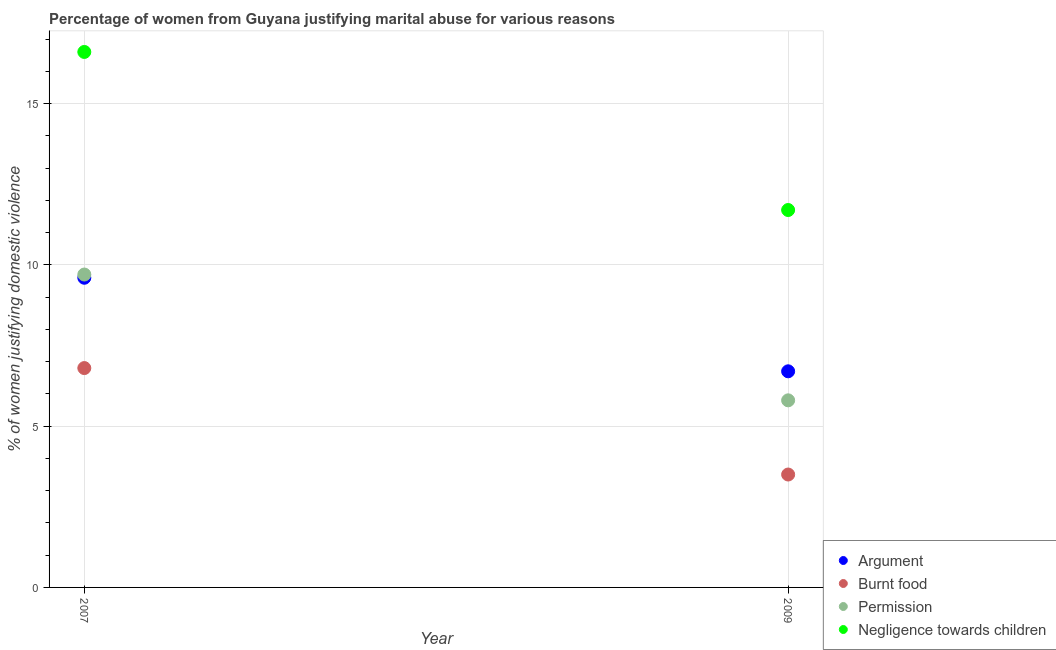How many different coloured dotlines are there?
Provide a short and direct response. 4. In which year was the percentage of women justifying abuse for going without permission maximum?
Your response must be concise. 2007. What is the total percentage of women justifying abuse for showing negligence towards children in the graph?
Offer a very short reply. 28.3. What is the difference between the percentage of women justifying abuse for showing negligence towards children in 2007 and the percentage of women justifying abuse for going without permission in 2009?
Your answer should be compact. 10.8. What is the average percentage of women justifying abuse for burning food per year?
Ensure brevity in your answer.  5.15. In the year 2009, what is the difference between the percentage of women justifying abuse in the case of an argument and percentage of women justifying abuse for burning food?
Offer a terse response. 3.2. In how many years, is the percentage of women justifying abuse in the case of an argument greater than 3 %?
Provide a succinct answer. 2. What is the ratio of the percentage of women justifying abuse for going without permission in 2007 to that in 2009?
Ensure brevity in your answer.  1.67. Is it the case that in every year, the sum of the percentage of women justifying abuse for burning food and percentage of women justifying abuse for showing negligence towards children is greater than the sum of percentage of women justifying abuse in the case of an argument and percentage of women justifying abuse for going without permission?
Offer a very short reply. No. Is it the case that in every year, the sum of the percentage of women justifying abuse in the case of an argument and percentage of women justifying abuse for burning food is greater than the percentage of women justifying abuse for going without permission?
Provide a short and direct response. Yes. Does the percentage of women justifying abuse for showing negligence towards children monotonically increase over the years?
Provide a succinct answer. No. Is the percentage of women justifying abuse for burning food strictly greater than the percentage of women justifying abuse for showing negligence towards children over the years?
Keep it short and to the point. No. How many dotlines are there?
Make the answer very short. 4. Does the graph contain grids?
Your response must be concise. Yes. What is the title of the graph?
Make the answer very short. Percentage of women from Guyana justifying marital abuse for various reasons. Does "Other greenhouse gases" appear as one of the legend labels in the graph?
Ensure brevity in your answer.  No. What is the label or title of the Y-axis?
Offer a very short reply. % of women justifying domestic violence. What is the % of women justifying domestic violence of Argument in 2007?
Keep it short and to the point. 9.6. What is the % of women justifying domestic violence of Burnt food in 2007?
Ensure brevity in your answer.  6.8. What is the % of women justifying domestic violence of Burnt food in 2009?
Provide a succinct answer. 3.5. What is the % of women justifying domestic violence of Permission in 2009?
Make the answer very short. 5.8. Across all years, what is the maximum % of women justifying domestic violence in Permission?
Provide a short and direct response. 9.7. Across all years, what is the maximum % of women justifying domestic violence in Negligence towards children?
Provide a succinct answer. 16.6. Across all years, what is the minimum % of women justifying domestic violence in Argument?
Offer a very short reply. 6.7. Across all years, what is the minimum % of women justifying domestic violence in Permission?
Provide a succinct answer. 5.8. What is the total % of women justifying domestic violence of Argument in the graph?
Your response must be concise. 16.3. What is the total % of women justifying domestic violence in Negligence towards children in the graph?
Keep it short and to the point. 28.3. What is the difference between the % of women justifying domestic violence of Burnt food in 2007 and that in 2009?
Make the answer very short. 3.3. What is the difference between the % of women justifying domestic violence in Argument in 2007 and the % of women justifying domestic violence in Burnt food in 2009?
Offer a very short reply. 6.1. What is the difference between the % of women justifying domestic violence in Argument in 2007 and the % of women justifying domestic violence in Permission in 2009?
Give a very brief answer. 3.8. What is the difference between the % of women justifying domestic violence of Argument in 2007 and the % of women justifying domestic violence of Negligence towards children in 2009?
Your answer should be compact. -2.1. What is the difference between the % of women justifying domestic violence in Burnt food in 2007 and the % of women justifying domestic violence in Permission in 2009?
Make the answer very short. 1. What is the difference between the % of women justifying domestic violence in Burnt food in 2007 and the % of women justifying domestic violence in Negligence towards children in 2009?
Offer a very short reply. -4.9. What is the difference between the % of women justifying domestic violence in Permission in 2007 and the % of women justifying domestic violence in Negligence towards children in 2009?
Your answer should be very brief. -2. What is the average % of women justifying domestic violence in Argument per year?
Give a very brief answer. 8.15. What is the average % of women justifying domestic violence in Burnt food per year?
Keep it short and to the point. 5.15. What is the average % of women justifying domestic violence of Permission per year?
Offer a terse response. 7.75. What is the average % of women justifying domestic violence of Negligence towards children per year?
Ensure brevity in your answer.  14.15. In the year 2007, what is the difference between the % of women justifying domestic violence of Argument and % of women justifying domestic violence of Burnt food?
Keep it short and to the point. 2.8. In the year 2007, what is the difference between the % of women justifying domestic violence in Argument and % of women justifying domestic violence in Permission?
Your answer should be compact. -0.1. In the year 2007, what is the difference between the % of women justifying domestic violence of Argument and % of women justifying domestic violence of Negligence towards children?
Offer a very short reply. -7. In the year 2007, what is the difference between the % of women justifying domestic violence in Burnt food and % of women justifying domestic violence in Negligence towards children?
Your answer should be very brief. -9.8. In the year 2007, what is the difference between the % of women justifying domestic violence in Permission and % of women justifying domestic violence in Negligence towards children?
Give a very brief answer. -6.9. In the year 2009, what is the difference between the % of women justifying domestic violence of Argument and % of women justifying domestic violence of Negligence towards children?
Your answer should be very brief. -5. In the year 2009, what is the difference between the % of women justifying domestic violence of Permission and % of women justifying domestic violence of Negligence towards children?
Give a very brief answer. -5.9. What is the ratio of the % of women justifying domestic violence in Argument in 2007 to that in 2009?
Give a very brief answer. 1.43. What is the ratio of the % of women justifying domestic violence of Burnt food in 2007 to that in 2009?
Keep it short and to the point. 1.94. What is the ratio of the % of women justifying domestic violence in Permission in 2007 to that in 2009?
Give a very brief answer. 1.67. What is the ratio of the % of women justifying domestic violence of Negligence towards children in 2007 to that in 2009?
Make the answer very short. 1.42. What is the difference between the highest and the second highest % of women justifying domestic violence of Burnt food?
Ensure brevity in your answer.  3.3. What is the difference between the highest and the second highest % of women justifying domestic violence of Negligence towards children?
Your answer should be compact. 4.9. What is the difference between the highest and the lowest % of women justifying domestic violence in Permission?
Provide a short and direct response. 3.9. What is the difference between the highest and the lowest % of women justifying domestic violence in Negligence towards children?
Provide a succinct answer. 4.9. 